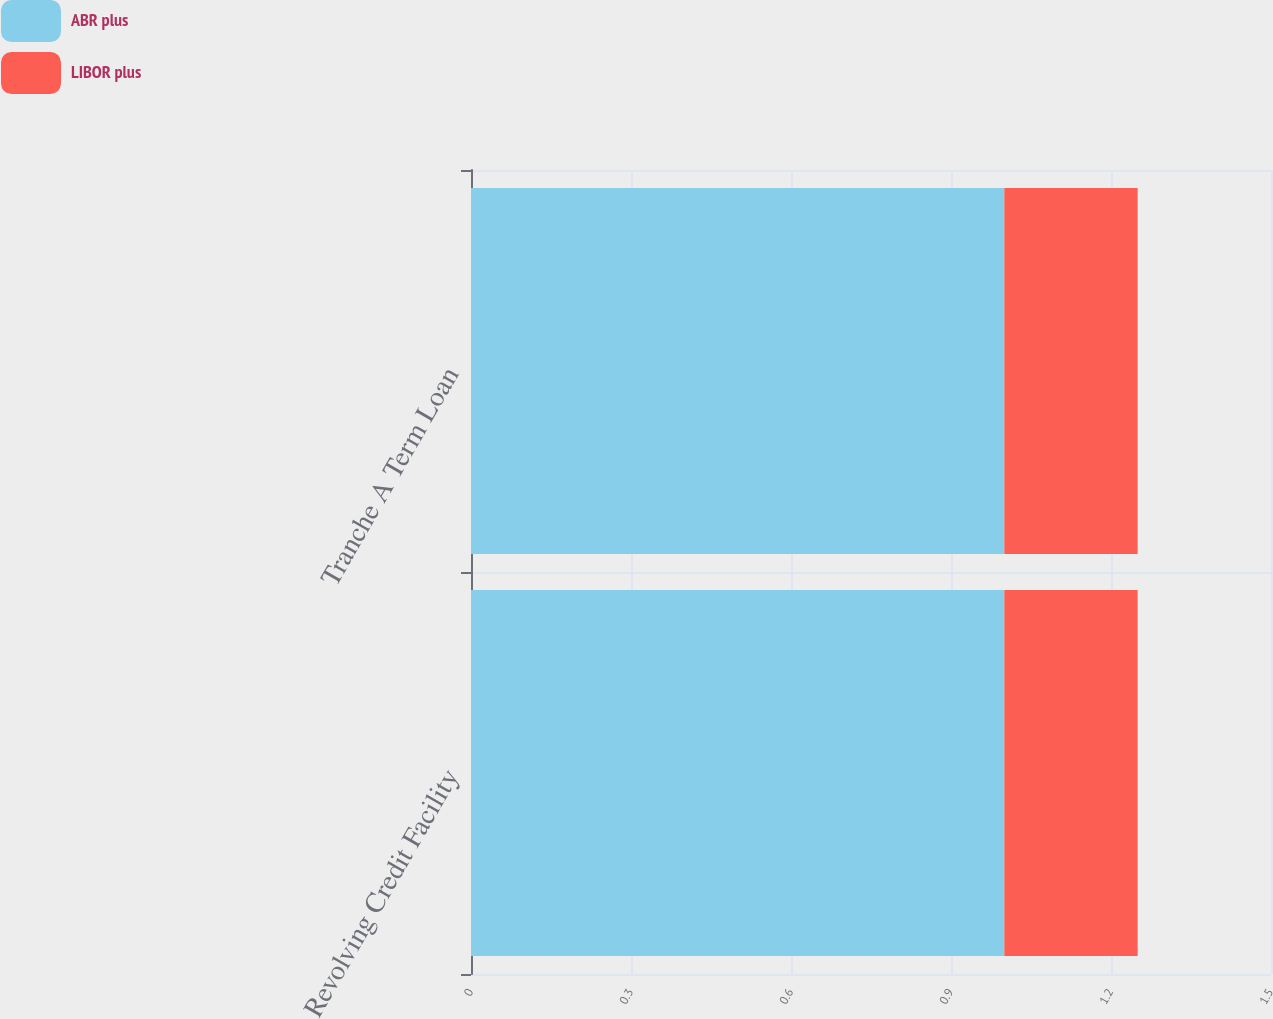Convert chart to OTSL. <chart><loc_0><loc_0><loc_500><loc_500><stacked_bar_chart><ecel><fcel>Revolving Credit Facility<fcel>Tranche A Term Loan<nl><fcel>ABR plus<fcel>1<fcel>1<nl><fcel>LIBOR plus<fcel>0.25<fcel>0.25<nl></chart> 